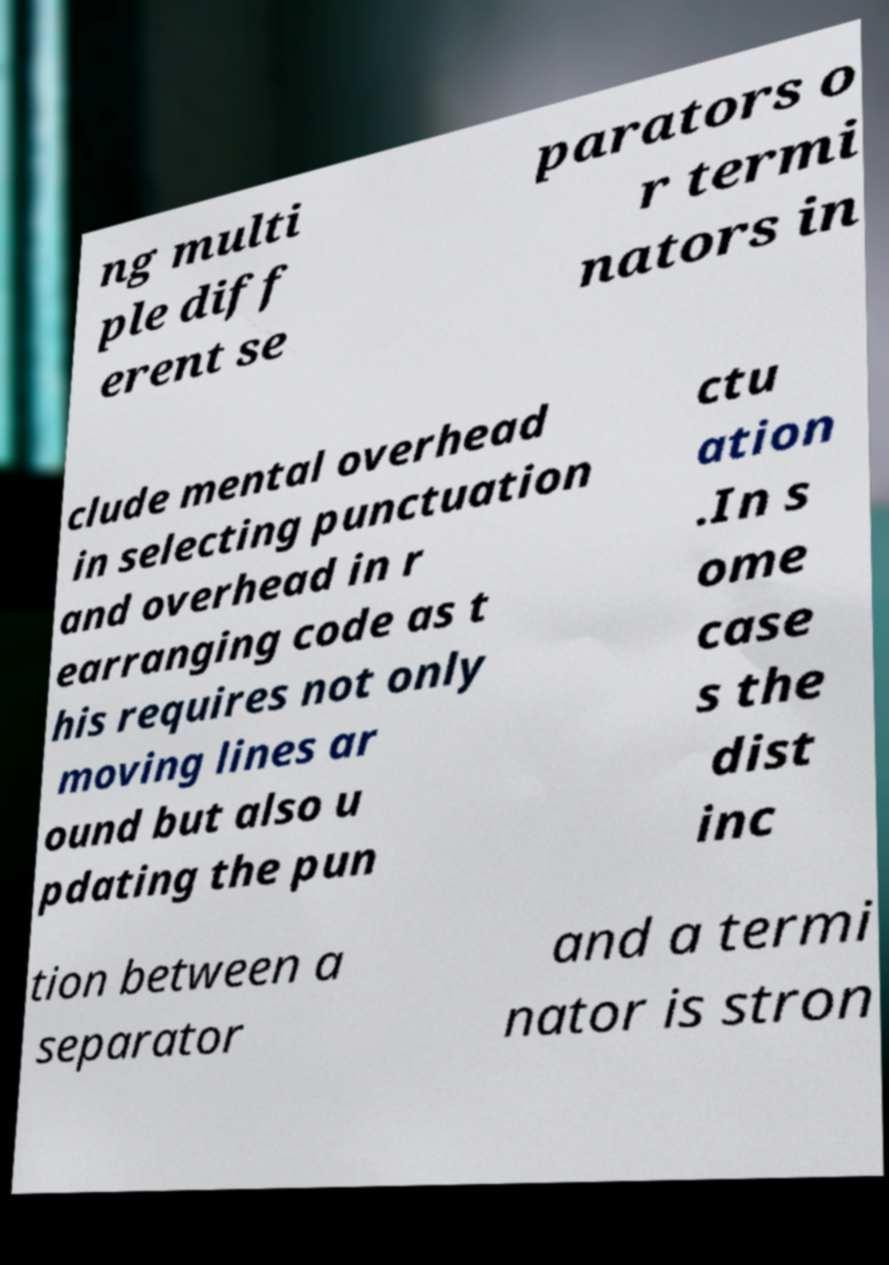Can you accurately transcribe the text from the provided image for me? ng multi ple diff erent se parators o r termi nators in clude mental overhead in selecting punctuation and overhead in r earranging code as t his requires not only moving lines ar ound but also u pdating the pun ctu ation .In s ome case s the dist inc tion between a separator and a termi nator is stron 